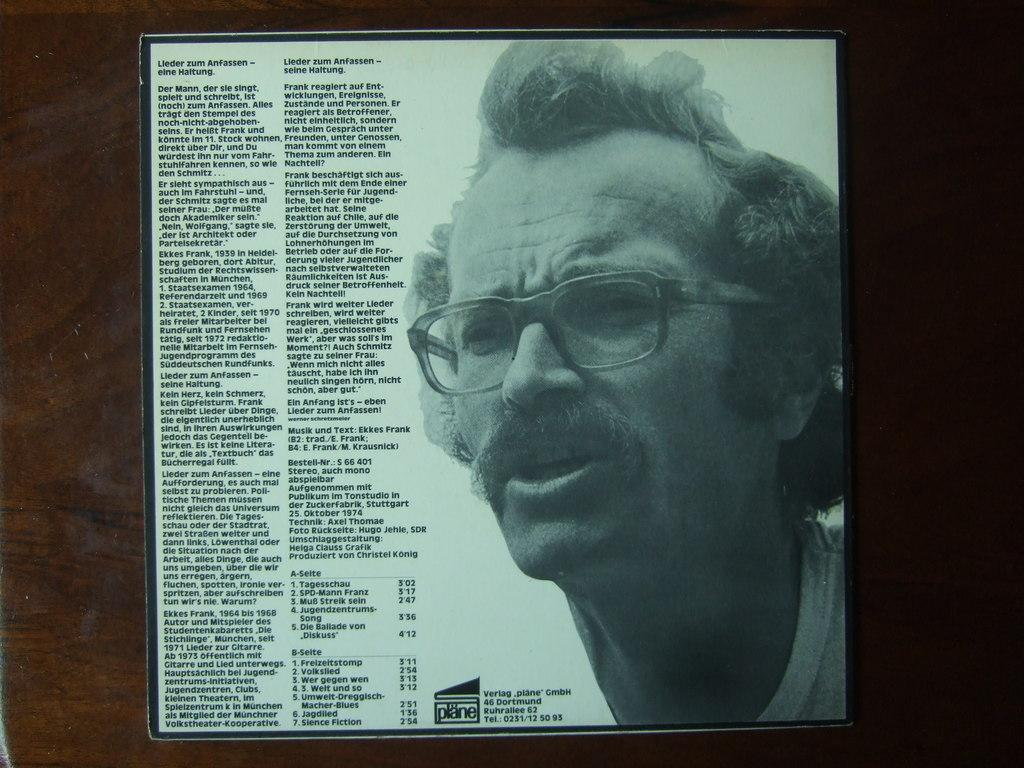What piece of furniture is present in the image? There is a table in the image. What is placed on the table? There is a frame on the table. What can be seen inside the frame? There is a person in the frame. What else is present in the frame besides the person? There is text in the frame. What type of peace can be seen in the image? There is no reference to peace in the image; it features a table, a frame, a person, and text. 